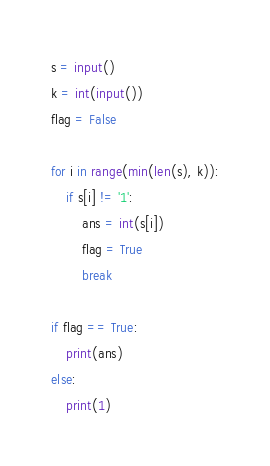Convert code to text. <code><loc_0><loc_0><loc_500><loc_500><_Python_>s = input()
k = int(input())
flag = False
 
for i in range(min(len(s), k)):
    if s[i] != '1':
        ans = int(s[i])
        flag = True
        break

if flag == True:
    print(ans)
else:
    print(1)</code> 